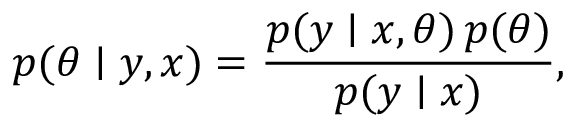Convert formula to latex. <formula><loc_0><loc_0><loc_500><loc_500>p ( \theta | y , x ) = \frac { p ( y | x , \theta ) \, p ( \theta ) } { p ( y | x ) } ,</formula> 